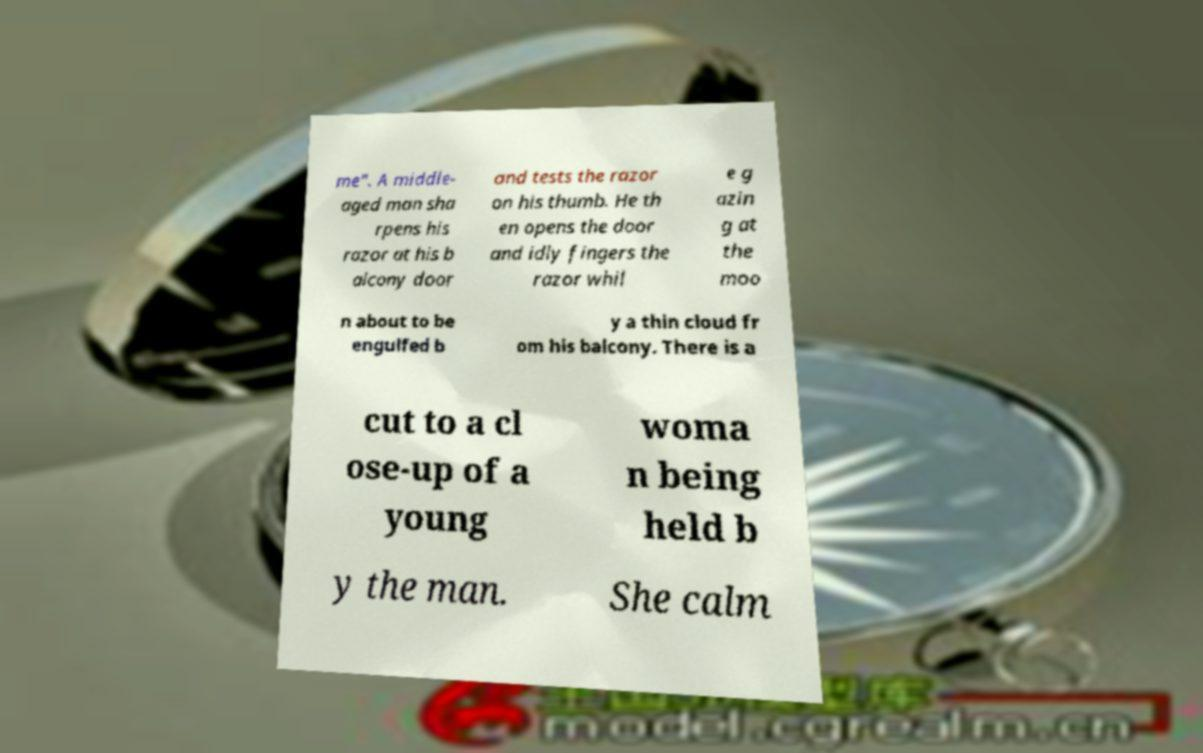Could you extract and type out the text from this image? me". A middle- aged man sha rpens his razor at his b alcony door and tests the razor on his thumb. He th en opens the door and idly fingers the razor whil e g azin g at the moo n about to be engulfed b y a thin cloud fr om his balcony. There is a cut to a cl ose-up of a young woma n being held b y the man. She calm 